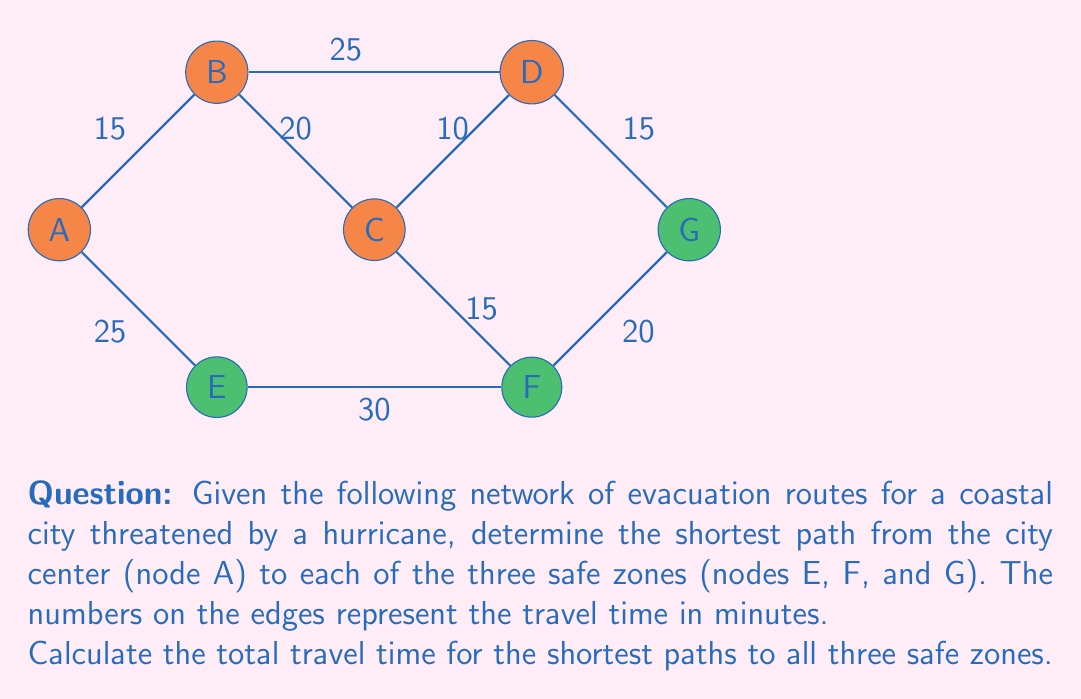Give your solution to this math problem. To solve this problem, we'll use Dijkstra's algorithm to find the shortest path from node A to each of the safe zones (E, F, and G). We'll then sum up the travel times for these shortest paths.

Step 1: Find the shortest path to node E
The direct path A-E is the only option, with a travel time of 25 minutes.

Step 2: Find the shortest path to node F
We have two options:
1. A-E-F: 25 + 30 = 55 minutes
2. A-B-C-F: 15 + 20 + 15 = 50 minutes
The shortest path to F is A-B-C-F with 50 minutes.

Step 3: Find the shortest path to node G
We have multiple options:
1. A-E-F-G: 25 + 30 + 20 = 75 minutes
2. A-B-C-D-G: 15 + 20 + 10 + 15 = 60 minutes
3. A-B-D-G: 15 + 25 + 15 = 55 minutes
The shortest path to G is A-B-D-G with 55 minutes.

Step 4: Calculate the total travel time
Sum up the travel times for the shortest paths to each safe zone:
$$\text{Total time} = t_E + t_F + t_G = 25 + 50 + 55 = 130\text{ minutes}$$
Answer: 130 minutes 